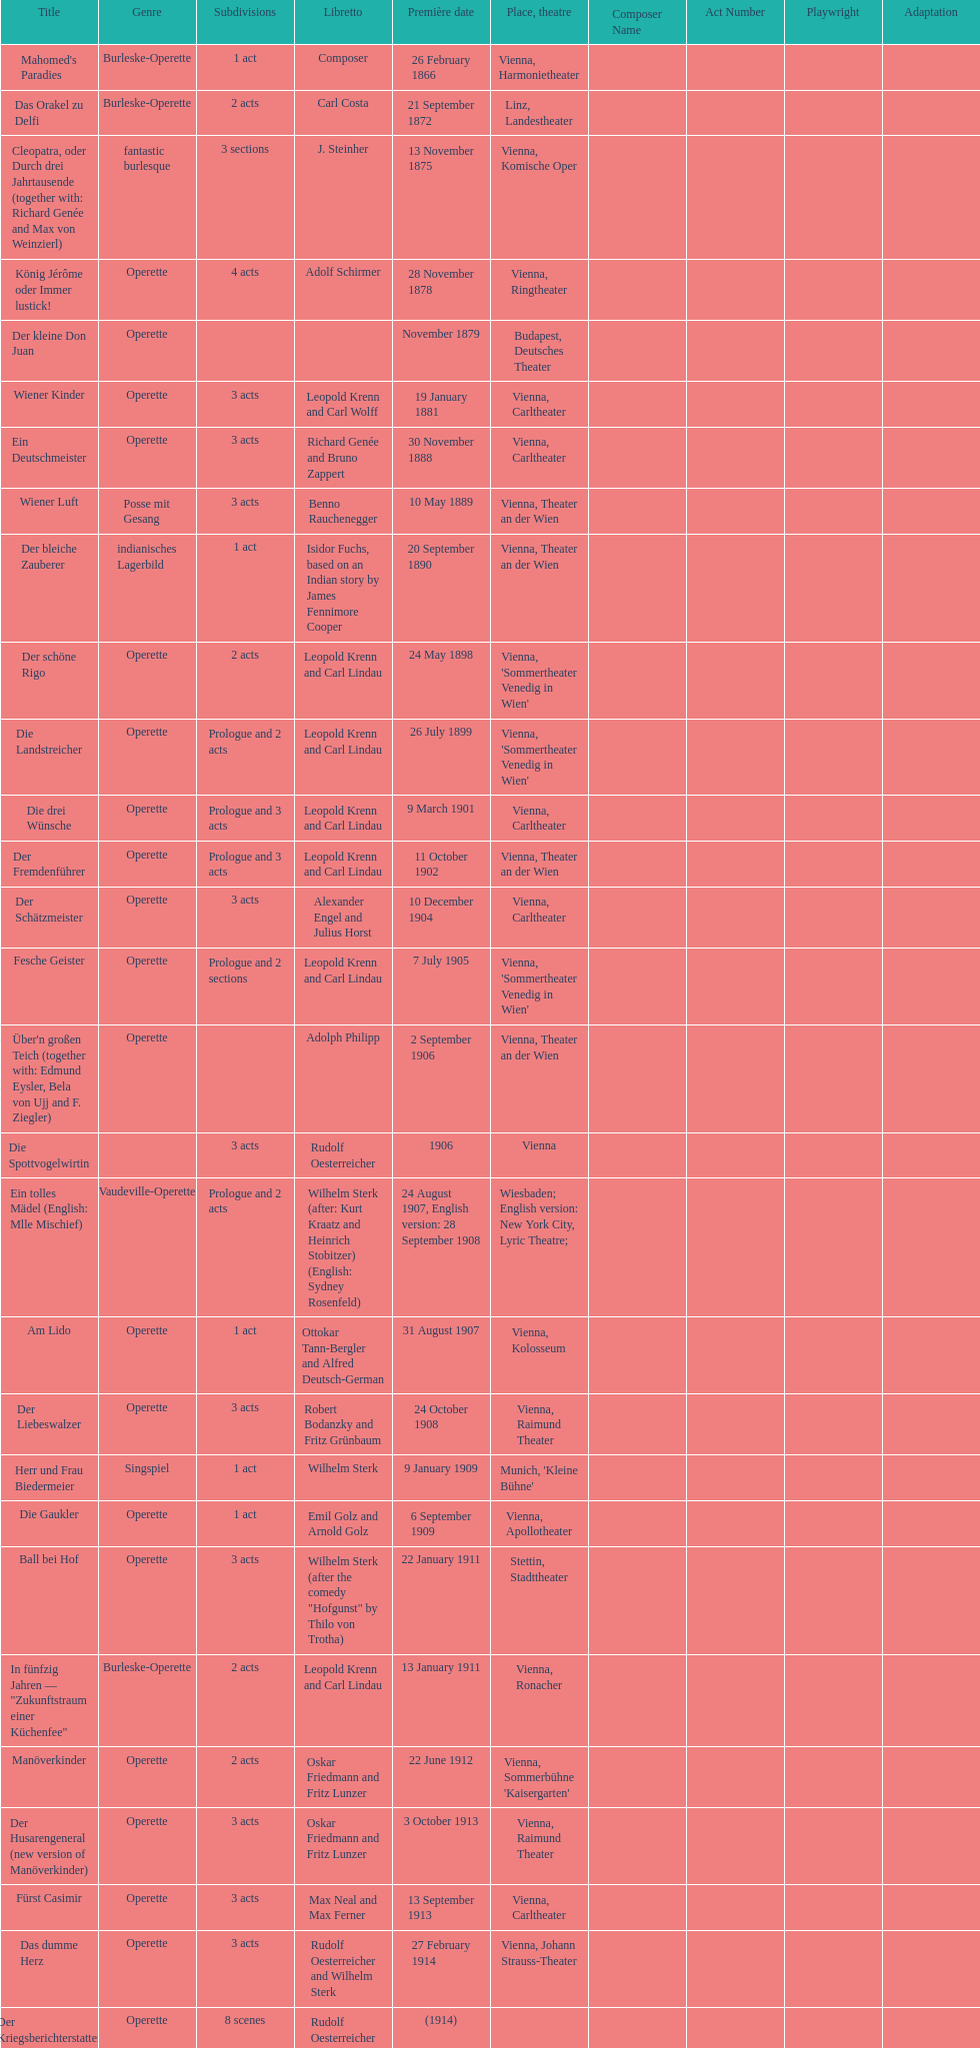Which genre is featured the most in this chart? Operette. 